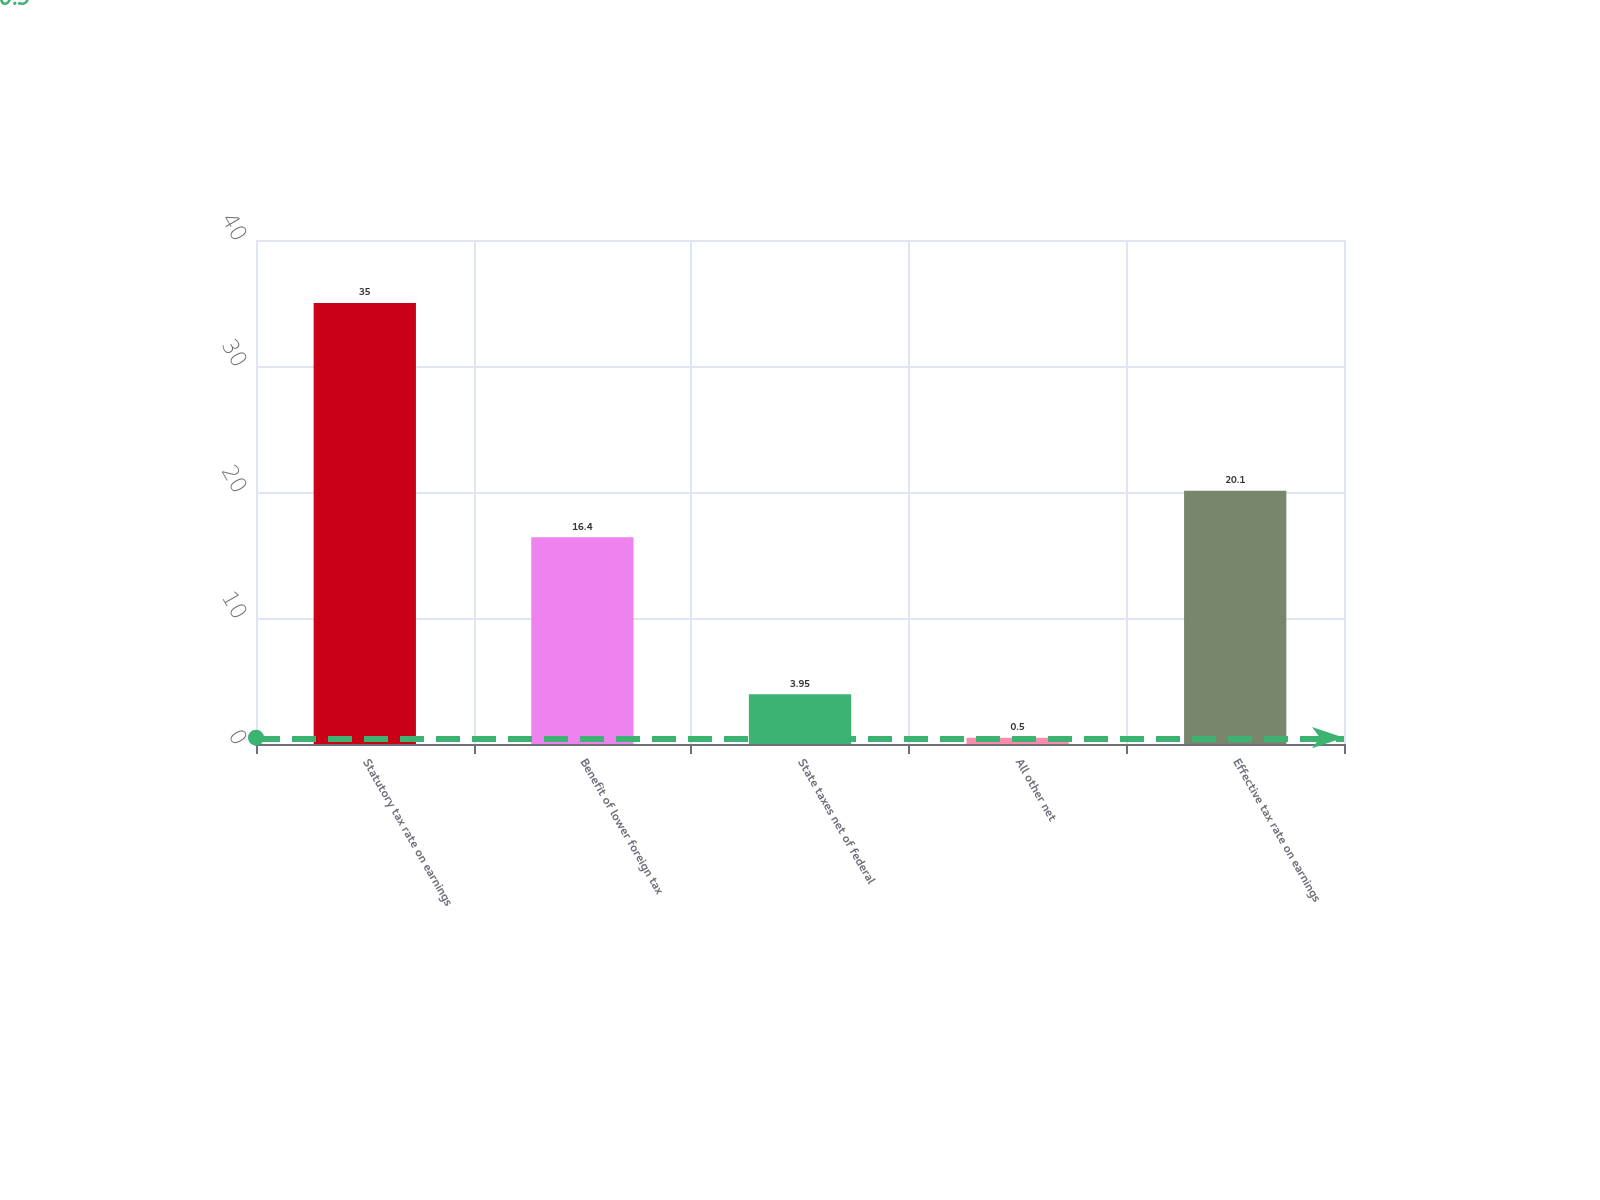<chart> <loc_0><loc_0><loc_500><loc_500><bar_chart><fcel>Statutory tax rate on earnings<fcel>Benefit of lower foreign tax<fcel>State taxes net of federal<fcel>All other net<fcel>Effective tax rate on earnings<nl><fcel>35<fcel>16.4<fcel>3.95<fcel>0.5<fcel>20.1<nl></chart> 